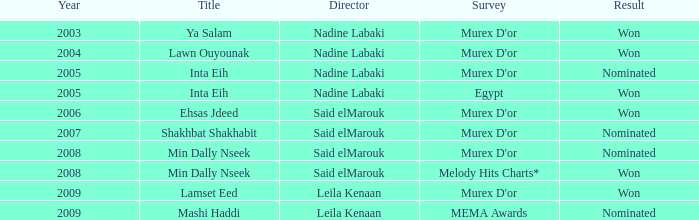Who is the director with the Min Dally Nseek title, and won? Said elMarouk. 